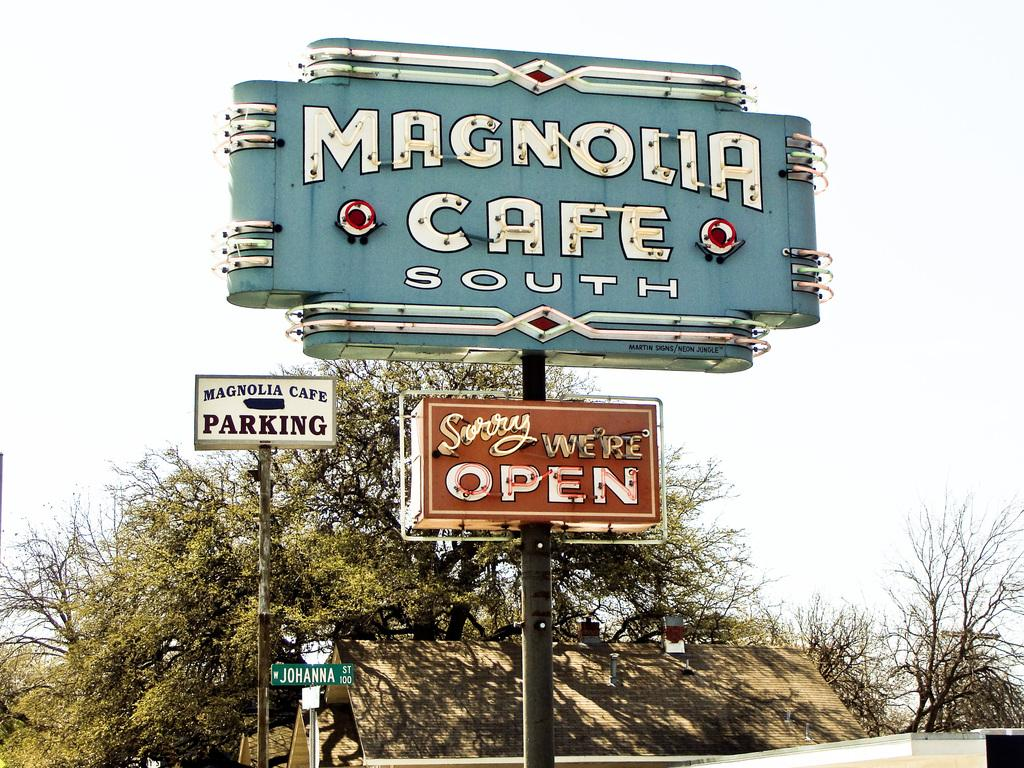What is located in the middle of the image? There are sign boards in the middle of the image. What type of vegetation can be seen in the background of the image? There are green color trees in the background. What is visible at the top of the image? The sky is visible at the top of the image. How many spiders are crawling on the sign boards in the image? There are no spiders present in the image; it only features sign boards, trees, and the sky. What rule is being enforced by the sign boards in the image? The sign boards in the image do not enforce any rules; they are simply objects in the scene. 